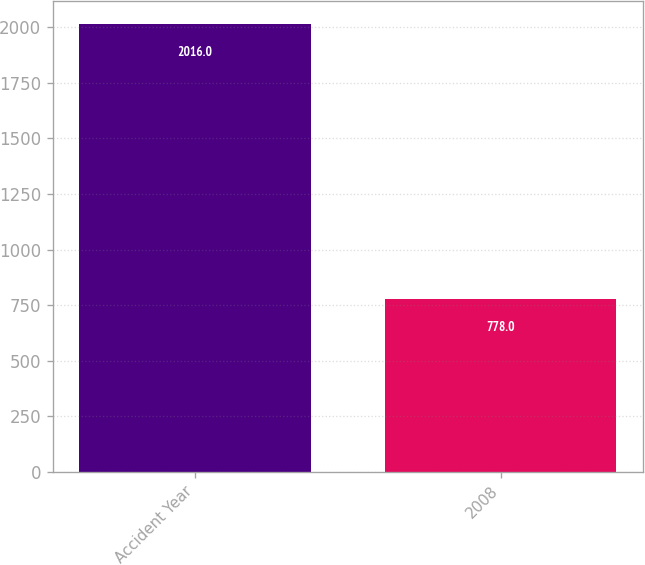Convert chart. <chart><loc_0><loc_0><loc_500><loc_500><bar_chart><fcel>Accident Year<fcel>2008<nl><fcel>2016<fcel>778<nl></chart> 